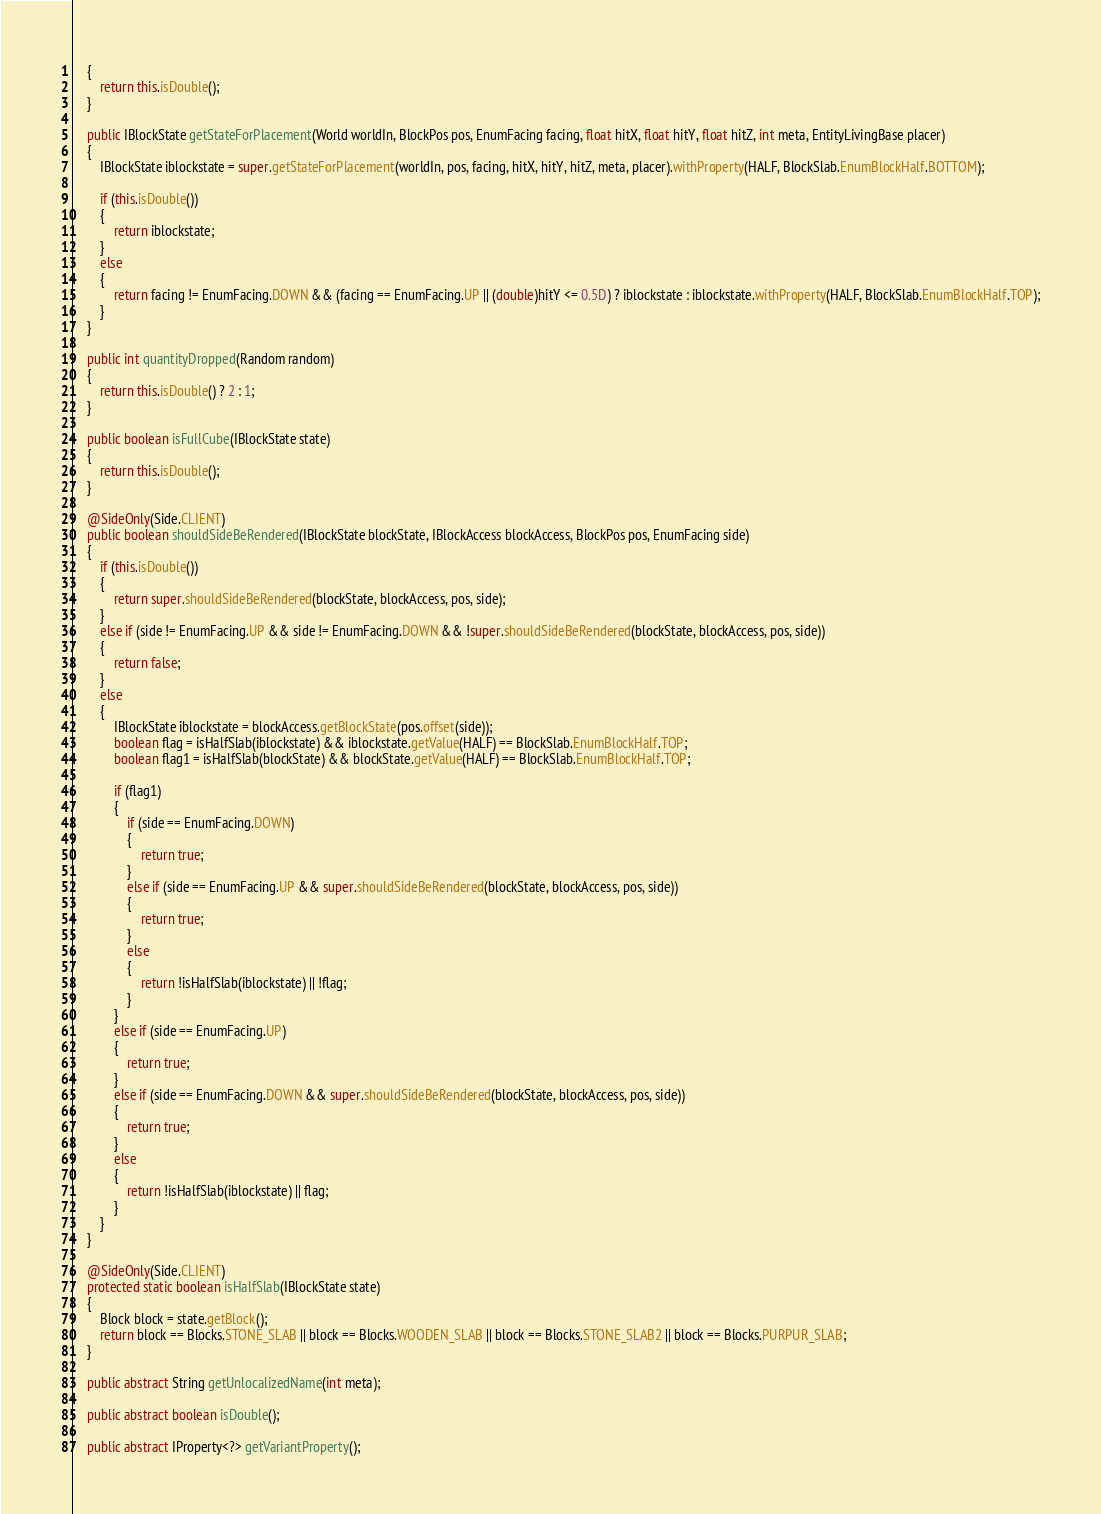<code> <loc_0><loc_0><loc_500><loc_500><_Java_>    {
        return this.isDouble();
    }

    public IBlockState getStateForPlacement(World worldIn, BlockPos pos, EnumFacing facing, float hitX, float hitY, float hitZ, int meta, EntityLivingBase placer)
    {
        IBlockState iblockstate = super.getStateForPlacement(worldIn, pos, facing, hitX, hitY, hitZ, meta, placer).withProperty(HALF, BlockSlab.EnumBlockHalf.BOTTOM);

        if (this.isDouble())
        {
            return iblockstate;
        }
        else
        {
            return facing != EnumFacing.DOWN && (facing == EnumFacing.UP || (double)hitY <= 0.5D) ? iblockstate : iblockstate.withProperty(HALF, BlockSlab.EnumBlockHalf.TOP);
        }
    }

    public int quantityDropped(Random random)
    {
        return this.isDouble() ? 2 : 1;
    }

    public boolean isFullCube(IBlockState state)
    {
        return this.isDouble();
    }

    @SideOnly(Side.CLIENT)
    public boolean shouldSideBeRendered(IBlockState blockState, IBlockAccess blockAccess, BlockPos pos, EnumFacing side)
    {
        if (this.isDouble())
        {
            return super.shouldSideBeRendered(blockState, blockAccess, pos, side);
        }
        else if (side != EnumFacing.UP && side != EnumFacing.DOWN && !super.shouldSideBeRendered(blockState, blockAccess, pos, side))
        {
            return false;
        }
        else
        {
            IBlockState iblockstate = blockAccess.getBlockState(pos.offset(side));
            boolean flag = isHalfSlab(iblockstate) && iblockstate.getValue(HALF) == BlockSlab.EnumBlockHalf.TOP;
            boolean flag1 = isHalfSlab(blockState) && blockState.getValue(HALF) == BlockSlab.EnumBlockHalf.TOP;

            if (flag1)
            {
                if (side == EnumFacing.DOWN)
                {
                    return true;
                }
                else if (side == EnumFacing.UP && super.shouldSideBeRendered(blockState, blockAccess, pos, side))
                {
                    return true;
                }
                else
                {
                    return !isHalfSlab(iblockstate) || !flag;
                }
            }
            else if (side == EnumFacing.UP)
            {
                return true;
            }
            else if (side == EnumFacing.DOWN && super.shouldSideBeRendered(blockState, blockAccess, pos, side))
            {
                return true;
            }
            else
            {
                return !isHalfSlab(iblockstate) || flag;
            }
        }
    }

    @SideOnly(Side.CLIENT)
    protected static boolean isHalfSlab(IBlockState state)
    {
        Block block = state.getBlock();
        return block == Blocks.STONE_SLAB || block == Blocks.WOODEN_SLAB || block == Blocks.STONE_SLAB2 || block == Blocks.PURPUR_SLAB;
    }

    public abstract String getUnlocalizedName(int meta);

    public abstract boolean isDouble();

    public abstract IProperty<?> getVariantProperty();
</code> 